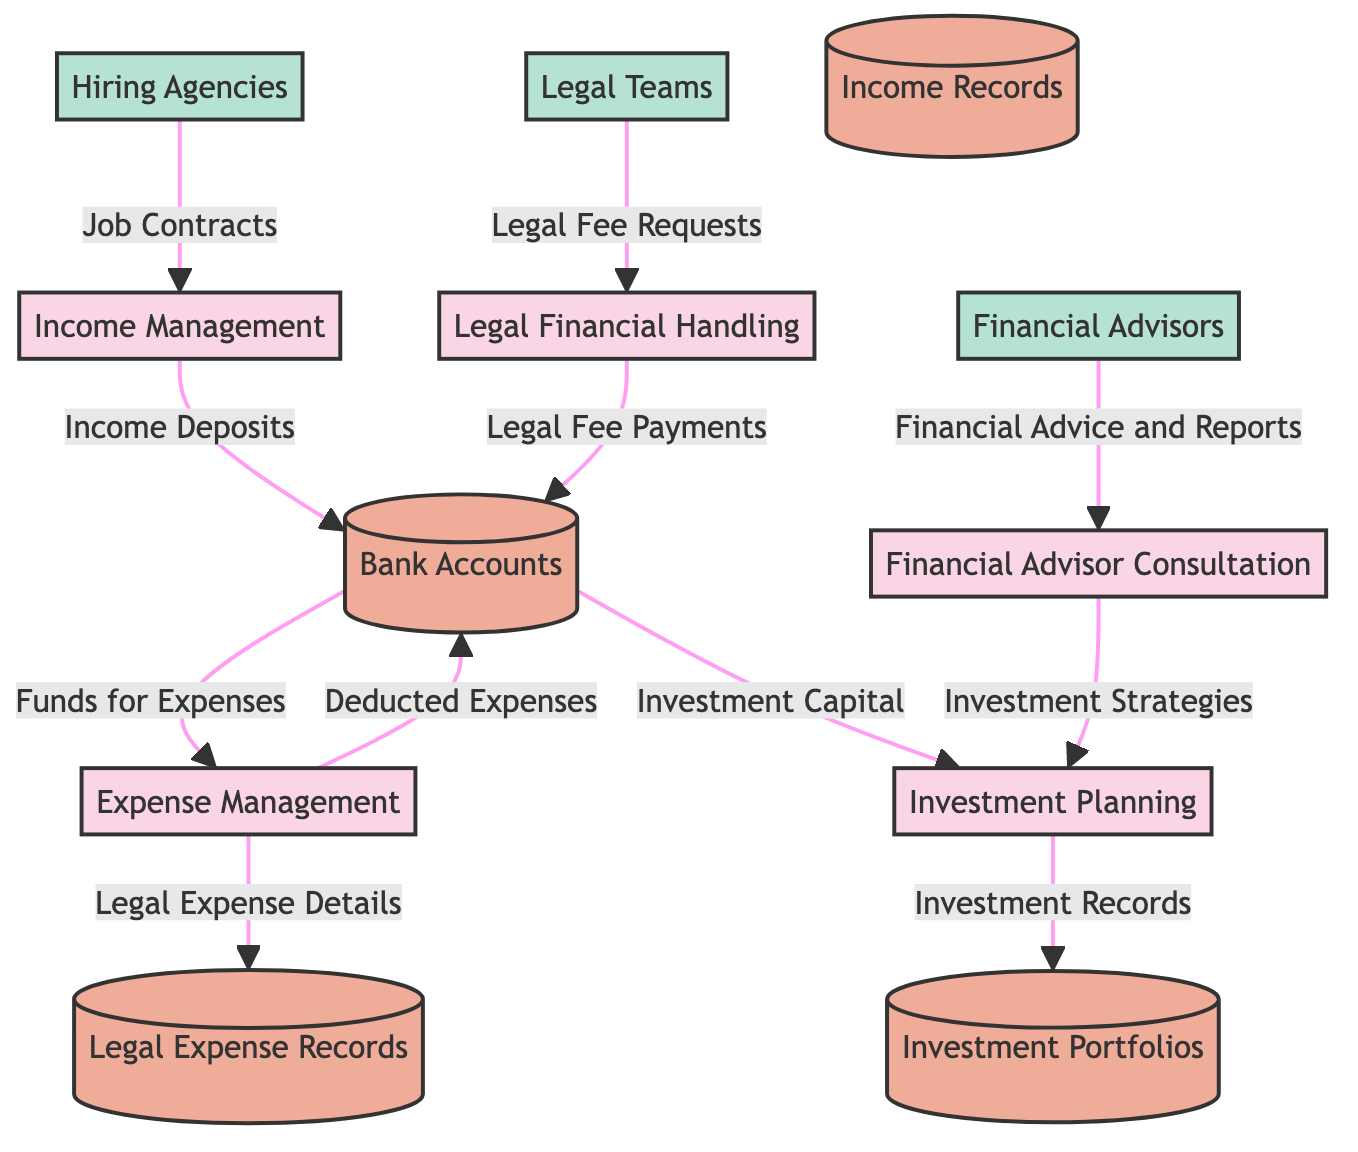What is the total number of processes in the diagram? In the diagram, there are five distinct processes labeled: Income Management, Expense Management, Legal Financial Handling, Investment Planning, and Financial Advisor Consultation. Counting these processes gives a total of five.
Answer: 5 Which external entity is associated with job contracts? The external entity connected to job contracts in the diagram is Hiring Agencies. This is shown as the source node that sends job contracts to the Income Management process.
Answer: Hiring Agencies How many data stores are present in the diagram? The diagram includes four data stores: Bank Accounts, Legal Expense Records, Income Records, and Investment Portfolios. By counting each distinct data store, we find that there are four in total.
Answer: 4 What type of information does Legal Financial Handling manage? The Legal Financial Handling process manages the costs associated with ongoing legal disputes, settlements, and attorney fees, which reflects its designated function in the diagram.
Answer: Legal Fee Requests What funds flow from Bank Accounts to Expense Management? The funds that flow from Bank Accounts to Expense Management are labeled "Funds for Expenses." This indicates that the expenses tracked are funded directly from bank accounts.
Answer: Funds for Expenses Which process receives investment strategies from Financial Advisor Consultation? The Investment Planning process receives investment strategies as output from the Financial Advisor Consultation process. The diagram shows this directed flow clearly.
Answer: Investment Planning What is the relationship between Expense Management and Legal Expense Records? The relationship between Expense Management and Legal Expense Records is that the Expense Management process sends details of legal expenses to Legal Expense Records. This data flow is explicitly indicated in the diagram.
Answer: Legal Expense Details Which external entity provides financial advice? The external entity providing financial advice is Financial Advisors. The diagram illustrates this connection clearly, showing that Financial Advisors send advice to the Financial Advisor Consultation process.
Answer: Financial Advisors What records are held in Legal Expense Records? Legal Expense Records contain detailed records of all expenses related to ongoing and past legal matters, as highlighted in the description of the data store in the diagram.
Answer: Legal Expense Records 